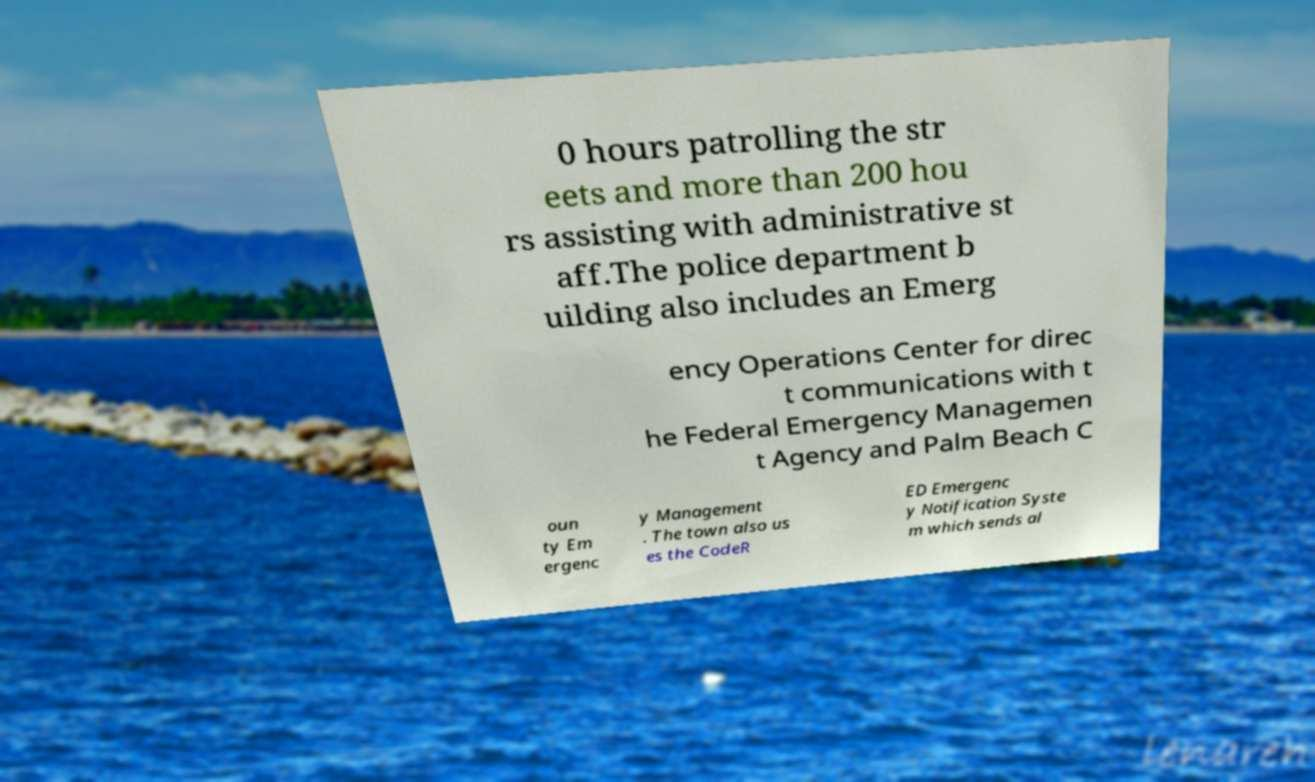Please identify and transcribe the text found in this image. 0 hours patrolling the str eets and more than 200 hou rs assisting with administrative st aff.The police department b uilding also includes an Emerg ency Operations Center for direc t communications with t he Federal Emergency Managemen t Agency and Palm Beach C oun ty Em ergenc y Management . The town also us es the CodeR ED Emergenc y Notification Syste m which sends al 